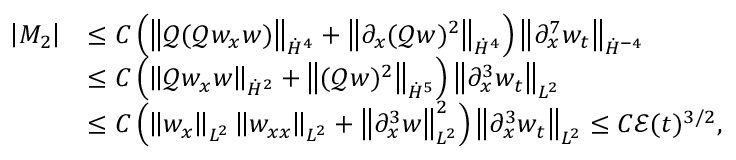Convert formula to latex. <formula><loc_0><loc_0><loc_500><loc_500>\begin{array} { r l } { \left | M _ { 2 } \right | } & { \leq C \left ( \left \| \ m a t h s c r { Q } ( \ m a t h s c r { Q } w _ { x } w ) \right \| _ { \dot { H } ^ { 4 } } + \left \| \partial _ { x } ( \ m a t h s c r { Q } w ) ^ { 2 } \right \| _ { \dot { H } ^ { 4 } } \right ) \left \| \partial _ { x } ^ { 7 } w _ { t } \right \| _ { \dot { H } ^ { - 4 } } } \\ & { \leq C \left ( \left \| \ m a t h s c r { Q } w _ { x } w \right \| _ { \dot { H } ^ { 2 } } + \left \| ( \ m a t h s c r { Q } w ) ^ { 2 } \right \| _ { \dot { H } ^ { 5 } } \right ) \left \| \partial _ { x } ^ { 3 } w _ { t } \right \| _ { L ^ { 2 } } } \\ & { \leq C \left ( \left \| w _ { x } \right \| _ { L ^ { 2 } } \left \| w _ { x x } \right \| _ { L ^ { 2 } } + \left \| \partial _ { x } ^ { 3 } w \right \| _ { L ^ { 2 } } ^ { 2 } \right ) \left \| \partial _ { x } ^ { 3 } w _ { t } \right \| _ { L ^ { 2 } } \leq C \mathcal { E } ( t ) ^ { 3 / 2 } , } \end{array}</formula> 